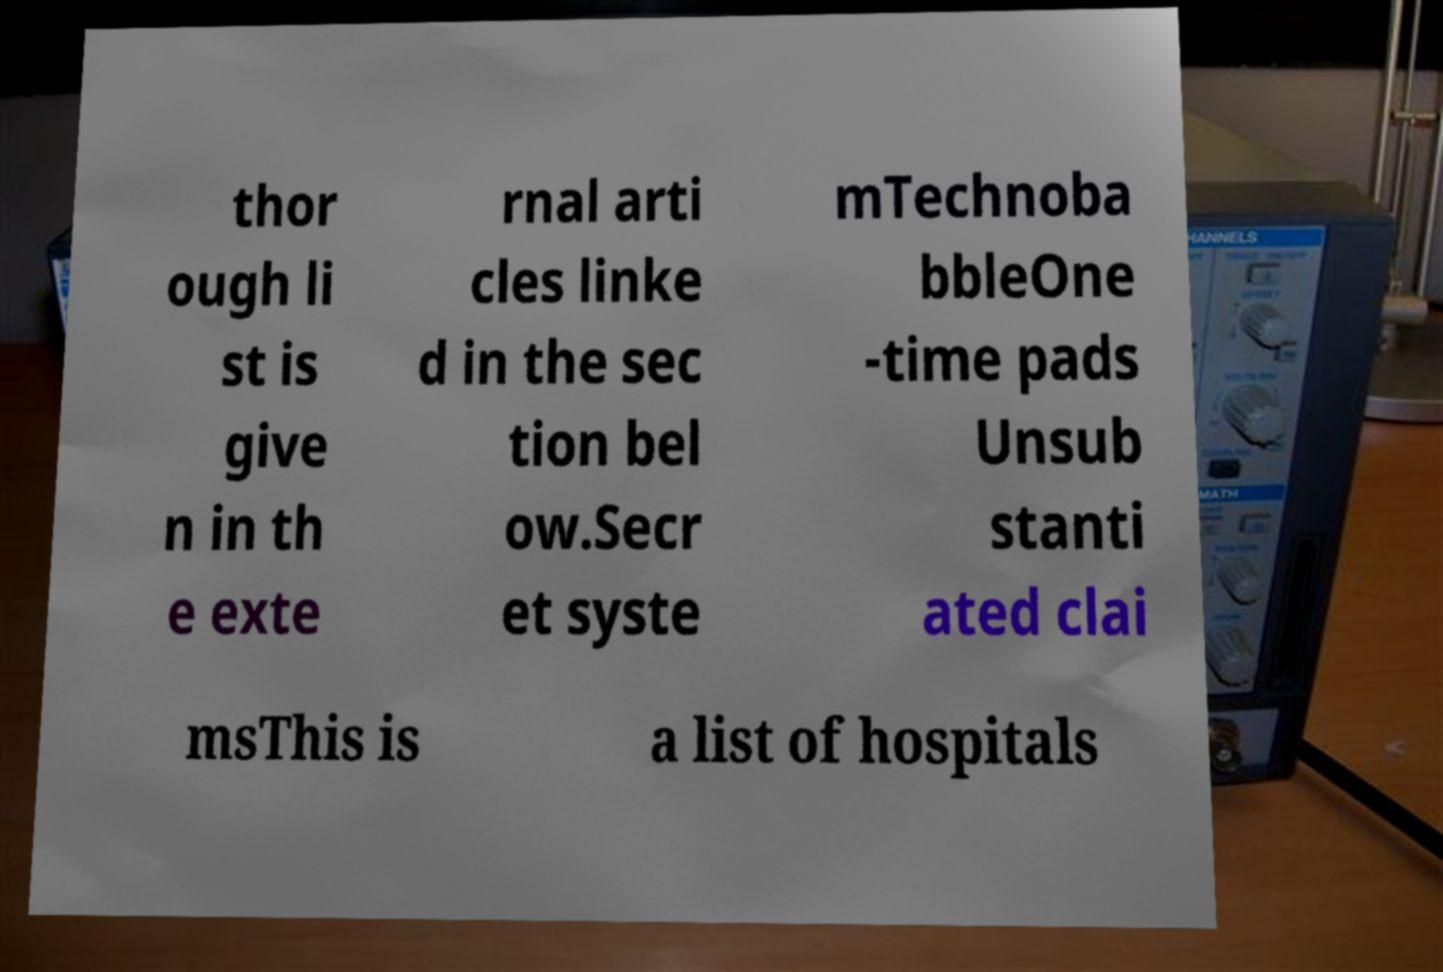Can you read and provide the text displayed in the image?This photo seems to have some interesting text. Can you extract and type it out for me? thor ough li st is give n in th e exte rnal arti cles linke d in the sec tion bel ow.Secr et syste mTechnoba bbleOne -time pads Unsub stanti ated clai msThis is a list of hospitals 